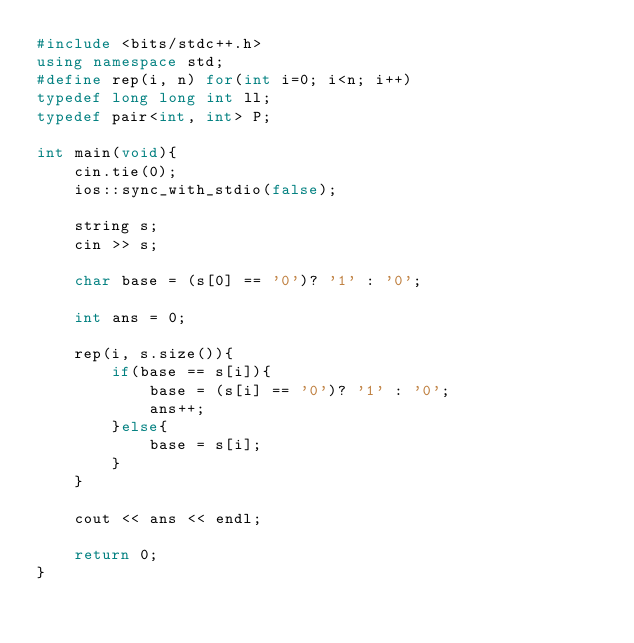<code> <loc_0><loc_0><loc_500><loc_500><_C++_>#include <bits/stdc++.h>
using namespace std;
#define rep(i, n) for(int i=0; i<n; i++)
typedef long long int ll;
typedef pair<int, int> P;

int main(void){
    cin.tie(0);
    ios::sync_with_stdio(false);

    string s;
    cin >> s;
    
    char base = (s[0] == '0')? '1' : '0';
    
    int ans = 0;
    
    rep(i, s.size()){
        if(base == s[i]){
            base = (s[i] == '0')? '1' : '0';
            ans++;
        }else{
            base = s[i];
        }
    }
    
    cout << ans << endl;

    return 0;
}</code> 